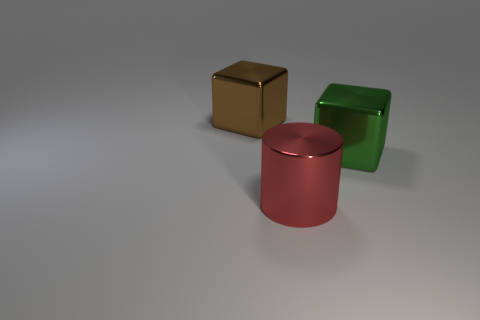There is a shiny block that is behind the large green thing; is there a cube in front of it?
Give a very brief answer. Yes. Are there any cyan objects that have the same size as the red shiny object?
Provide a short and direct response. No. There is a big shiny cube left of the big green shiny block; does it have the same color as the metallic cylinder?
Make the answer very short. No. What is the size of the brown block?
Give a very brief answer. Large. What is the size of the block in front of the large object that is behind the green block?
Make the answer very short. Large. What number of metallic cubes have the same color as the big metal cylinder?
Your response must be concise. 0. What number of big red metallic cylinders are there?
Offer a very short reply. 1. What number of big cyan balls have the same material as the green thing?
Ensure brevity in your answer.  0. What is the size of the other thing that is the same shape as the big brown metal thing?
Offer a very short reply. Large. What is the green block made of?
Offer a terse response. Metal. 